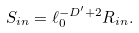Convert formula to latex. <formula><loc_0><loc_0><loc_500><loc_500>S _ { i n } = \ell _ { 0 } ^ { - D ^ { \prime } + 2 } R _ { i n } .</formula> 